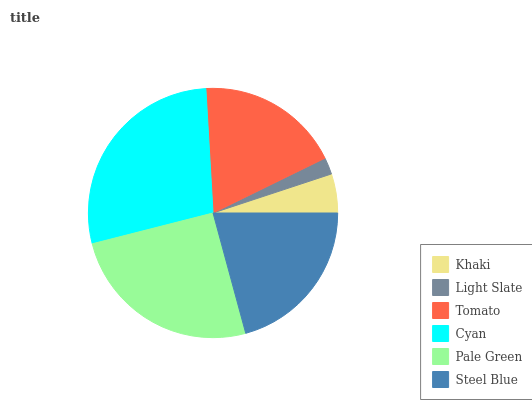Is Light Slate the minimum?
Answer yes or no. Yes. Is Cyan the maximum?
Answer yes or no. Yes. Is Tomato the minimum?
Answer yes or no. No. Is Tomato the maximum?
Answer yes or no. No. Is Tomato greater than Light Slate?
Answer yes or no. Yes. Is Light Slate less than Tomato?
Answer yes or no. Yes. Is Light Slate greater than Tomato?
Answer yes or no. No. Is Tomato less than Light Slate?
Answer yes or no. No. Is Steel Blue the high median?
Answer yes or no. Yes. Is Tomato the low median?
Answer yes or no. Yes. Is Tomato the high median?
Answer yes or no. No. Is Pale Green the low median?
Answer yes or no. No. 